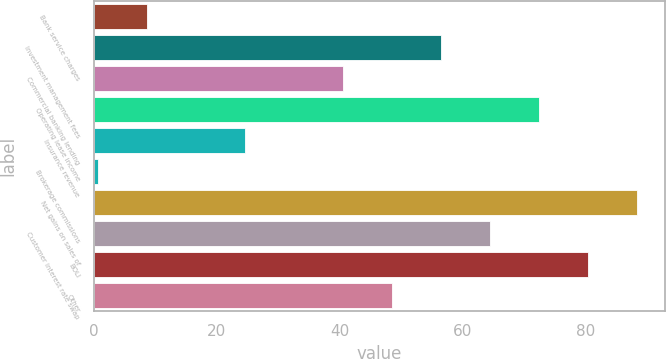Convert chart. <chart><loc_0><loc_0><loc_500><loc_500><bar_chart><fcel>Bank service charges<fcel>Investment management fees<fcel>Commercial banking lending<fcel>Operating lease income<fcel>Insurance revenue<fcel>Brokerage commissions<fcel>Net gains on sales of<fcel>Customer interest rate swap<fcel>BOLI<fcel>Other<nl><fcel>8.67<fcel>56.49<fcel>40.55<fcel>72.43<fcel>24.61<fcel>0.7<fcel>88.37<fcel>64.46<fcel>80.4<fcel>48.52<nl></chart> 